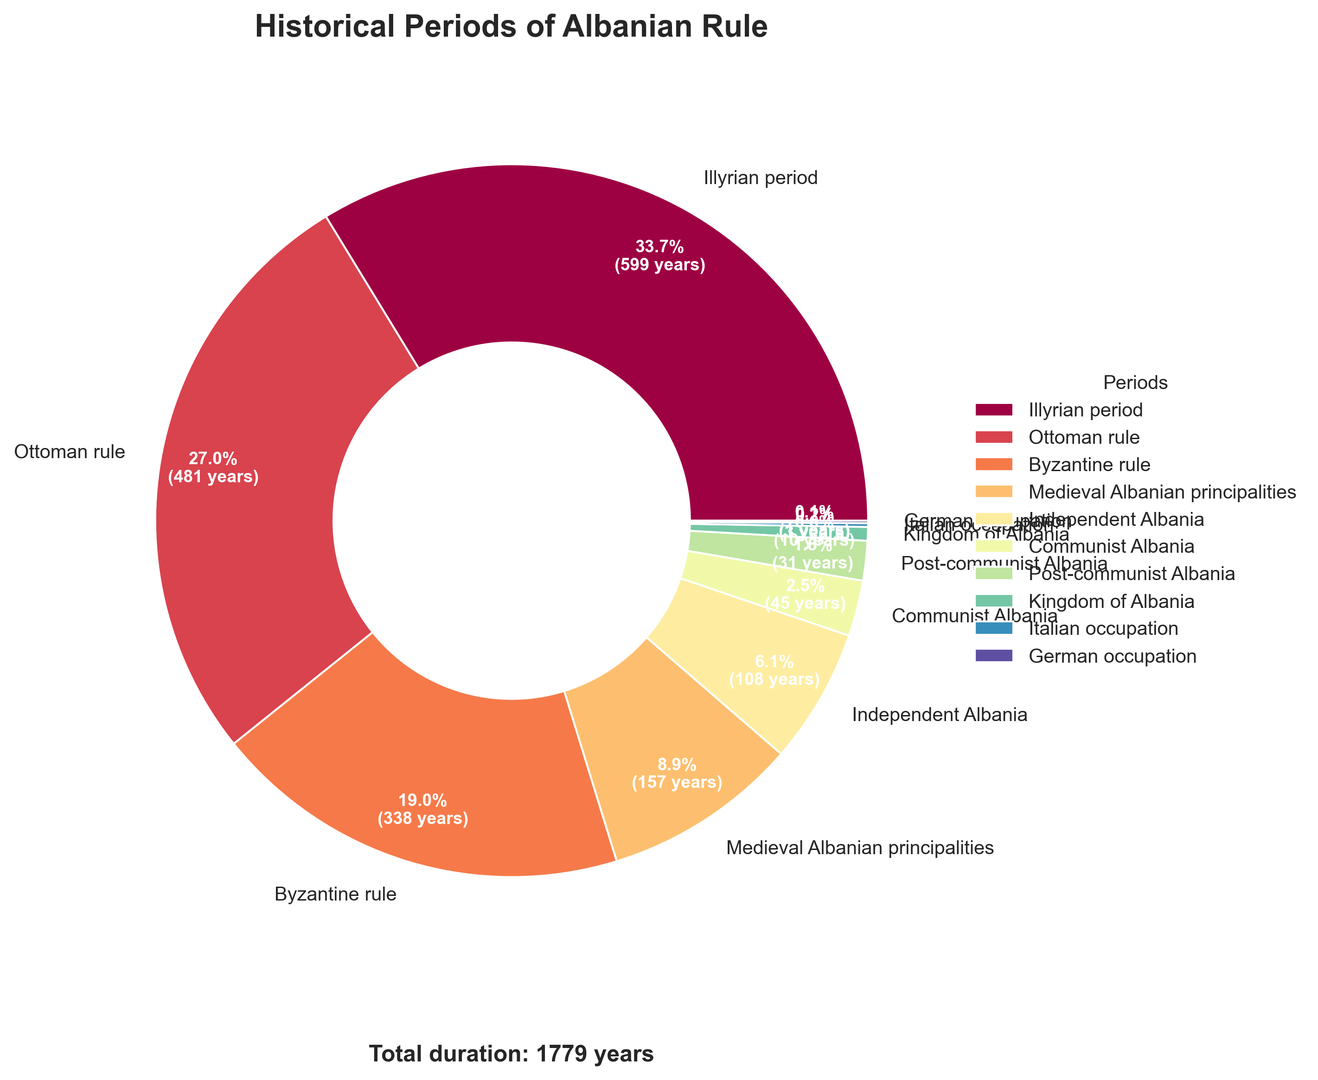What historical period accounts for the largest portion of the pie chart? The visual inspection of the pie chart shows that the Illyrian period has the largest segment. The size of the wedge is significantly larger compared to other periods.
Answer: Illyrian period Which historical period lasted the shortest? The visual inspection of the pie chart indicates that the German occupation has the smallest segment, suggesting it had the shortest duration.
Answer: German occupation What is the combined duration of both the German and Italian occupations? The duration of the German occupation is 2 years and the Italian occupation is 3 years. Summing them up gives 2 + 3 = 5 years.
Answer: 5 years Which two historical periods together make up more than 50% of the total duration? The two largest segments are the Illyrian period and the Ottoman rule. The Illyrian period is 600 years and the Ottoman rule is 481 years. Their combined duration is 600 + 481 = 1081 years, which is more than 50% of the total duration of 1779 years.
Answer: Illyrian period and Ottoman rule How does the duration of the Medieval Albanian principalities period compare to the Communist Albania period? The duration of the Medieval Albanian principalities is 158 years, while the duration of the Communist Albania period is 45 years. By comparing these two values, 158 is significantly greater than 45.
Answer: Medieval Albanian principalities lasted longer What color is used to represent the Byzantine rule period? The pie chart uses a range of colors, and the Byzantine rule period segment is distinctly colored, typically appearing near the mid-spectral range such as green or teal based on the spectral color map.
Answer: Green or teal What percentage of the total duration is covered by the Post-communist Albania period? The Post-communist Albania period lasted 32 years. The total duration of all periods is 1779 years. The percentage is calculated as (32 / 1779) * 100, which is approximately 1.8%.
Answer: 1.8% What is the difference in years between the Byzantine rule period and the Ottoman rule period? The Byzantine rule lasted 338 years, and the Ottoman rule lasted 481 years. The difference in years is 481 - 338 = 143 years.
Answer: 143 years Which historical period directly follows the Byzantine rule in terms of duration? After Byzantine rule, the next historical period in descending order of duration is Ottoman rule.
Answer: Ottoman rule What are the third and fourth longest historical periods shown in the pie chart? Based on the size of the segments, the third longest period is Byzantine rule (338 years) and the fourth longest period is Medieval Albanian principalities (158 years).
Answer: Byzantine rule and Medieval Albanian principalities 